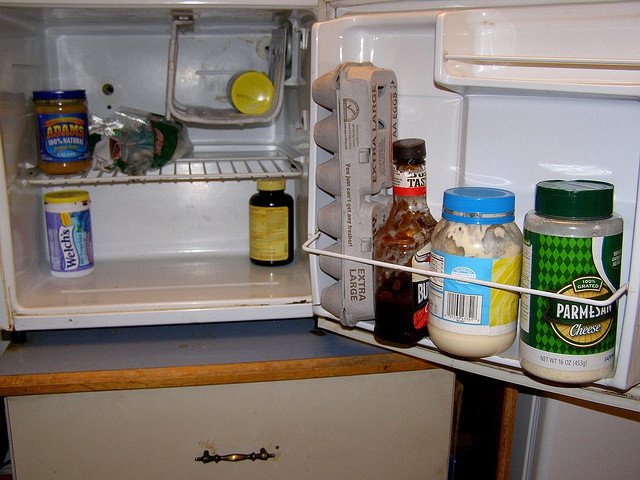Describe the objects in this image and their specific colors. I can see refrigerator in gray, darkgray, lightgray, and black tones, bottle in gray, black, darkgray, and darkgreen tones, bottle in gray, darkgray, lightgray, and tan tones, bottle in gray, black, and maroon tones, and bottle in gray, black, maroon, and navy tones in this image. 